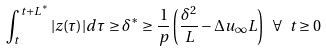Convert formula to latex. <formula><loc_0><loc_0><loc_500><loc_500>\int _ { t } ^ { t + L ^ { \ast } } | z ( \tau ) | d \tau \geq \delta ^ { \ast } \geq \frac { 1 } { p } \left ( \frac { \delta ^ { 2 } } { L } - \Delta u _ { \infty } L \right ) \ \forall \ t \geq 0</formula> 